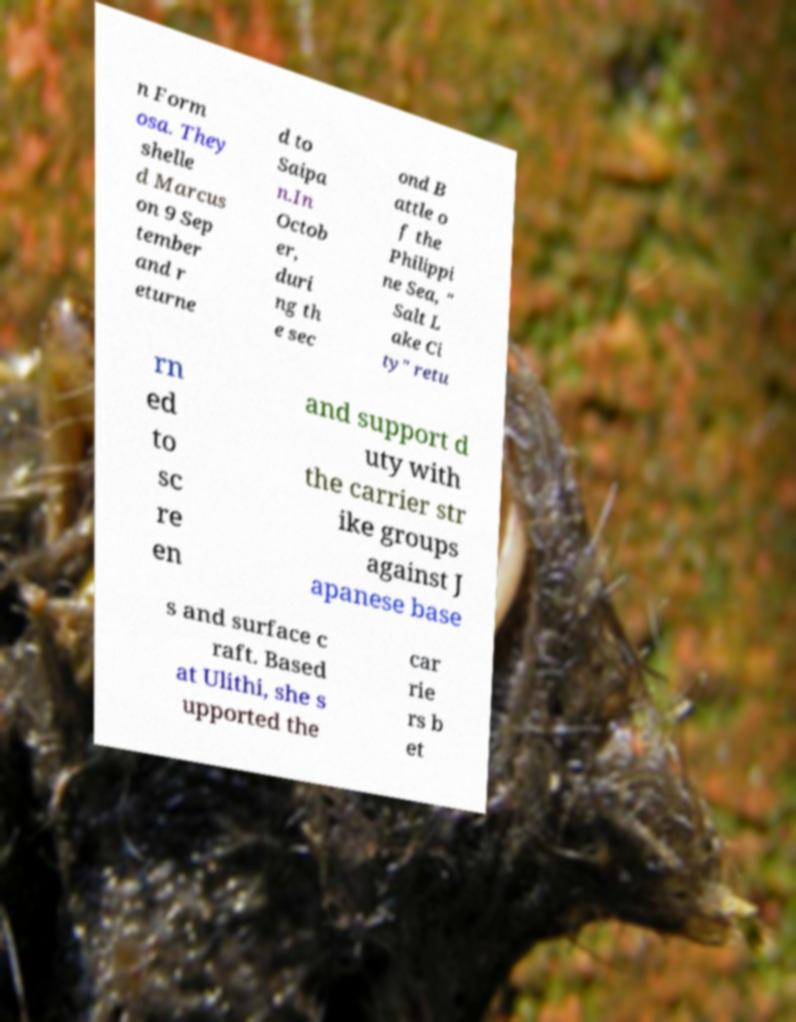Please identify and transcribe the text found in this image. n Form osa. They shelle d Marcus on 9 Sep tember and r eturne d to Saipa n.In Octob er, duri ng th e sec ond B attle o f the Philippi ne Sea, " Salt L ake Ci ty" retu rn ed to sc re en and support d uty with the carrier str ike groups against J apanese base s and surface c raft. Based at Ulithi, she s upported the car rie rs b et 